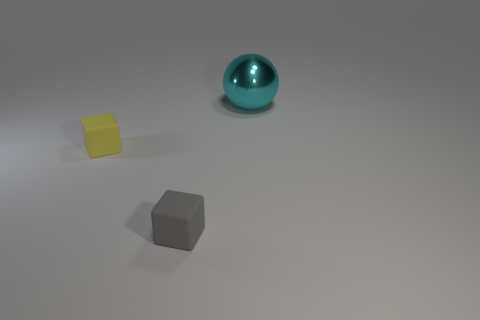Subtract all blocks. How many objects are left? 1 Add 1 large cyan shiny balls. How many objects exist? 4 Subtract all small yellow rubber blocks. Subtract all small yellow objects. How many objects are left? 1 Add 3 tiny blocks. How many tiny blocks are left? 5 Add 2 small cyan rubber cubes. How many small cyan rubber cubes exist? 2 Subtract all gray cubes. How many cubes are left? 1 Subtract 0 green cylinders. How many objects are left? 3 Subtract all green blocks. Subtract all cyan cylinders. How many blocks are left? 2 Subtract all green balls. How many gray blocks are left? 1 